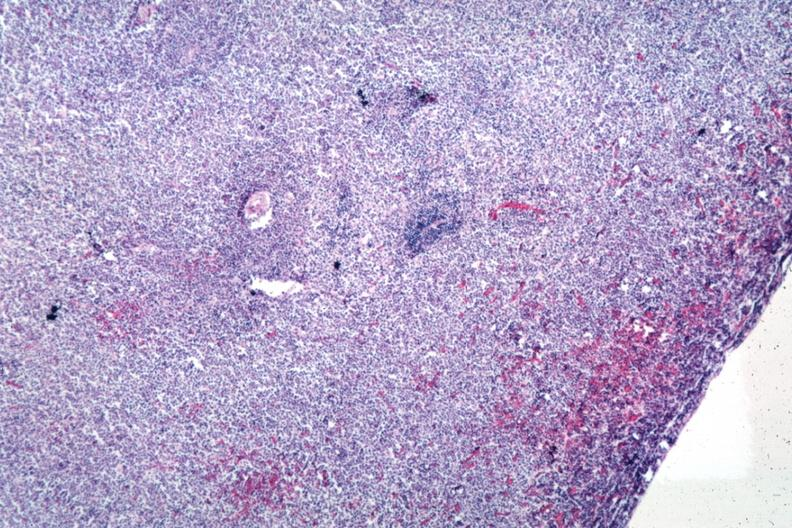s intestine present?
Answer the question using a single word or phrase. No 